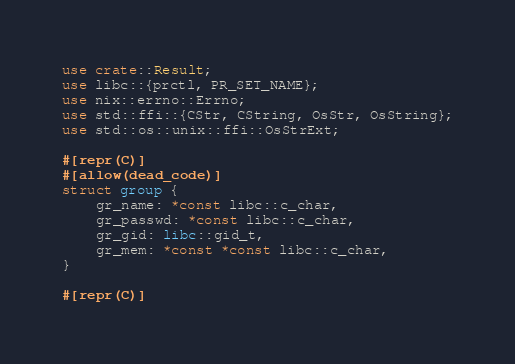Convert code to text. <code><loc_0><loc_0><loc_500><loc_500><_Rust_>use crate::Result;
use libc::{prctl, PR_SET_NAME};
use nix::errno::Errno;
use std::ffi::{CStr, CString, OsStr, OsString};
use std::os::unix::ffi::OsStrExt;

#[repr(C)]
#[allow(dead_code)]
struct group {
    gr_name: *const libc::c_char,
    gr_passwd: *const libc::c_char,
    gr_gid: libc::gid_t,
    gr_mem: *const *const libc::c_char,
}

#[repr(C)]</code> 